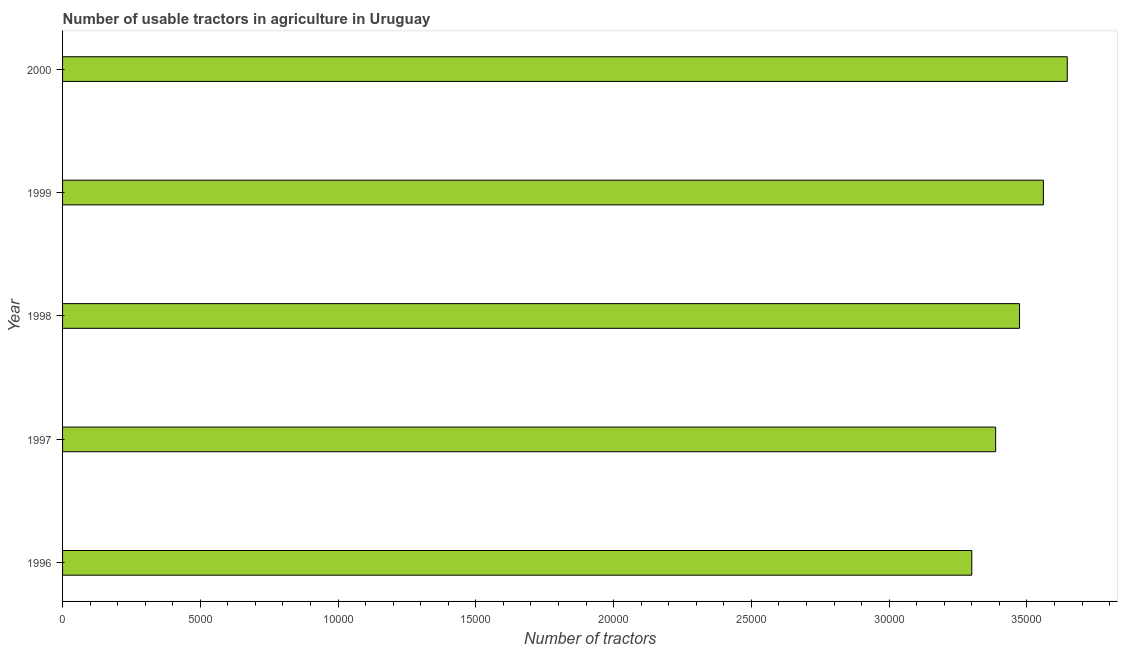Does the graph contain any zero values?
Give a very brief answer. No. Does the graph contain grids?
Your response must be concise. No. What is the title of the graph?
Provide a short and direct response. Number of usable tractors in agriculture in Uruguay. What is the label or title of the X-axis?
Your answer should be compact. Number of tractors. What is the label or title of the Y-axis?
Your response must be concise. Year. What is the number of tractors in 1999?
Give a very brief answer. 3.56e+04. Across all years, what is the maximum number of tractors?
Make the answer very short. 3.65e+04. Across all years, what is the minimum number of tractors?
Provide a short and direct response. 3.30e+04. In which year was the number of tractors maximum?
Ensure brevity in your answer.  2000. What is the sum of the number of tractors?
Give a very brief answer. 1.74e+05. What is the difference between the number of tractors in 1996 and 1997?
Make the answer very short. -866. What is the average number of tractors per year?
Your response must be concise. 3.47e+04. What is the median number of tractors?
Provide a short and direct response. 3.47e+04. What is the ratio of the number of tractors in 1996 to that in 2000?
Keep it short and to the point. 0.91. Is the difference between the number of tractors in 1998 and 1999 greater than the difference between any two years?
Keep it short and to the point. No. What is the difference between the highest and the second highest number of tractors?
Your answer should be compact. 866. Is the sum of the number of tractors in 1996 and 1999 greater than the maximum number of tractors across all years?
Your answer should be very brief. Yes. What is the difference between the highest and the lowest number of tractors?
Provide a short and direct response. 3465. Are all the bars in the graph horizontal?
Your answer should be very brief. Yes. What is the difference between two consecutive major ticks on the X-axis?
Your answer should be compact. 5000. What is the Number of tractors in 1996?
Your response must be concise. 3.30e+04. What is the Number of tractors in 1997?
Make the answer very short. 3.39e+04. What is the Number of tractors in 1998?
Your answer should be compact. 3.47e+04. What is the Number of tractors of 1999?
Your answer should be very brief. 3.56e+04. What is the Number of tractors in 2000?
Make the answer very short. 3.65e+04. What is the difference between the Number of tractors in 1996 and 1997?
Give a very brief answer. -866. What is the difference between the Number of tractors in 1996 and 1998?
Your answer should be compact. -1732. What is the difference between the Number of tractors in 1996 and 1999?
Your response must be concise. -2599. What is the difference between the Number of tractors in 1996 and 2000?
Your response must be concise. -3465. What is the difference between the Number of tractors in 1997 and 1998?
Make the answer very short. -866. What is the difference between the Number of tractors in 1997 and 1999?
Keep it short and to the point. -1733. What is the difference between the Number of tractors in 1997 and 2000?
Give a very brief answer. -2599. What is the difference between the Number of tractors in 1998 and 1999?
Offer a terse response. -867. What is the difference between the Number of tractors in 1998 and 2000?
Your response must be concise. -1733. What is the difference between the Number of tractors in 1999 and 2000?
Ensure brevity in your answer.  -866. What is the ratio of the Number of tractors in 1996 to that in 1997?
Offer a very short reply. 0.97. What is the ratio of the Number of tractors in 1996 to that in 1998?
Your answer should be compact. 0.95. What is the ratio of the Number of tractors in 1996 to that in 1999?
Provide a short and direct response. 0.93. What is the ratio of the Number of tractors in 1996 to that in 2000?
Keep it short and to the point. 0.91. What is the ratio of the Number of tractors in 1997 to that in 1998?
Provide a short and direct response. 0.97. What is the ratio of the Number of tractors in 1997 to that in 1999?
Your response must be concise. 0.95. What is the ratio of the Number of tractors in 1997 to that in 2000?
Ensure brevity in your answer.  0.93. What is the ratio of the Number of tractors in 1998 to that in 2000?
Provide a succinct answer. 0.95. What is the ratio of the Number of tractors in 1999 to that in 2000?
Your answer should be compact. 0.98. 